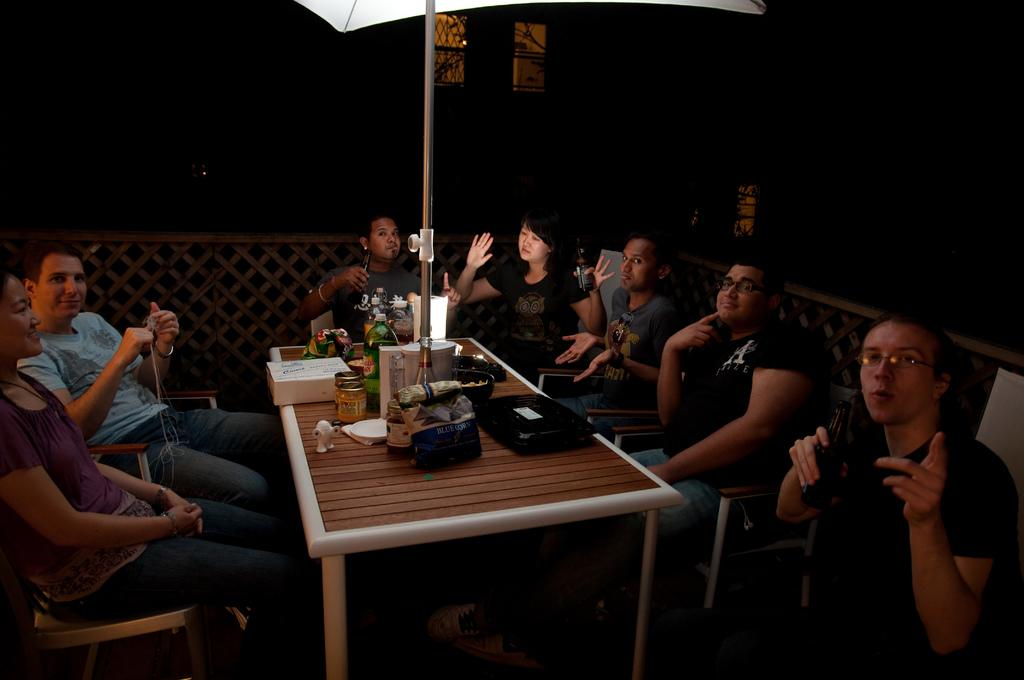How many people are in the image? There is a group of people in the people in the image, but the exact number is not specified. What are the people doing in the image? The people are seated on chairs in the image. What objects are in front of the people? There are jars, a bottle, a flower vase, and a box in front of the people. What other object is present in the image? There is an umbrella on the table in the image. What type of dirt can be seen on the floor in the image? There is no dirt visible on the floor in the image. How many bananas are being held by the people in the image? There is no mention of bananas in the image, so we cannot determine how many are being held by the people. 